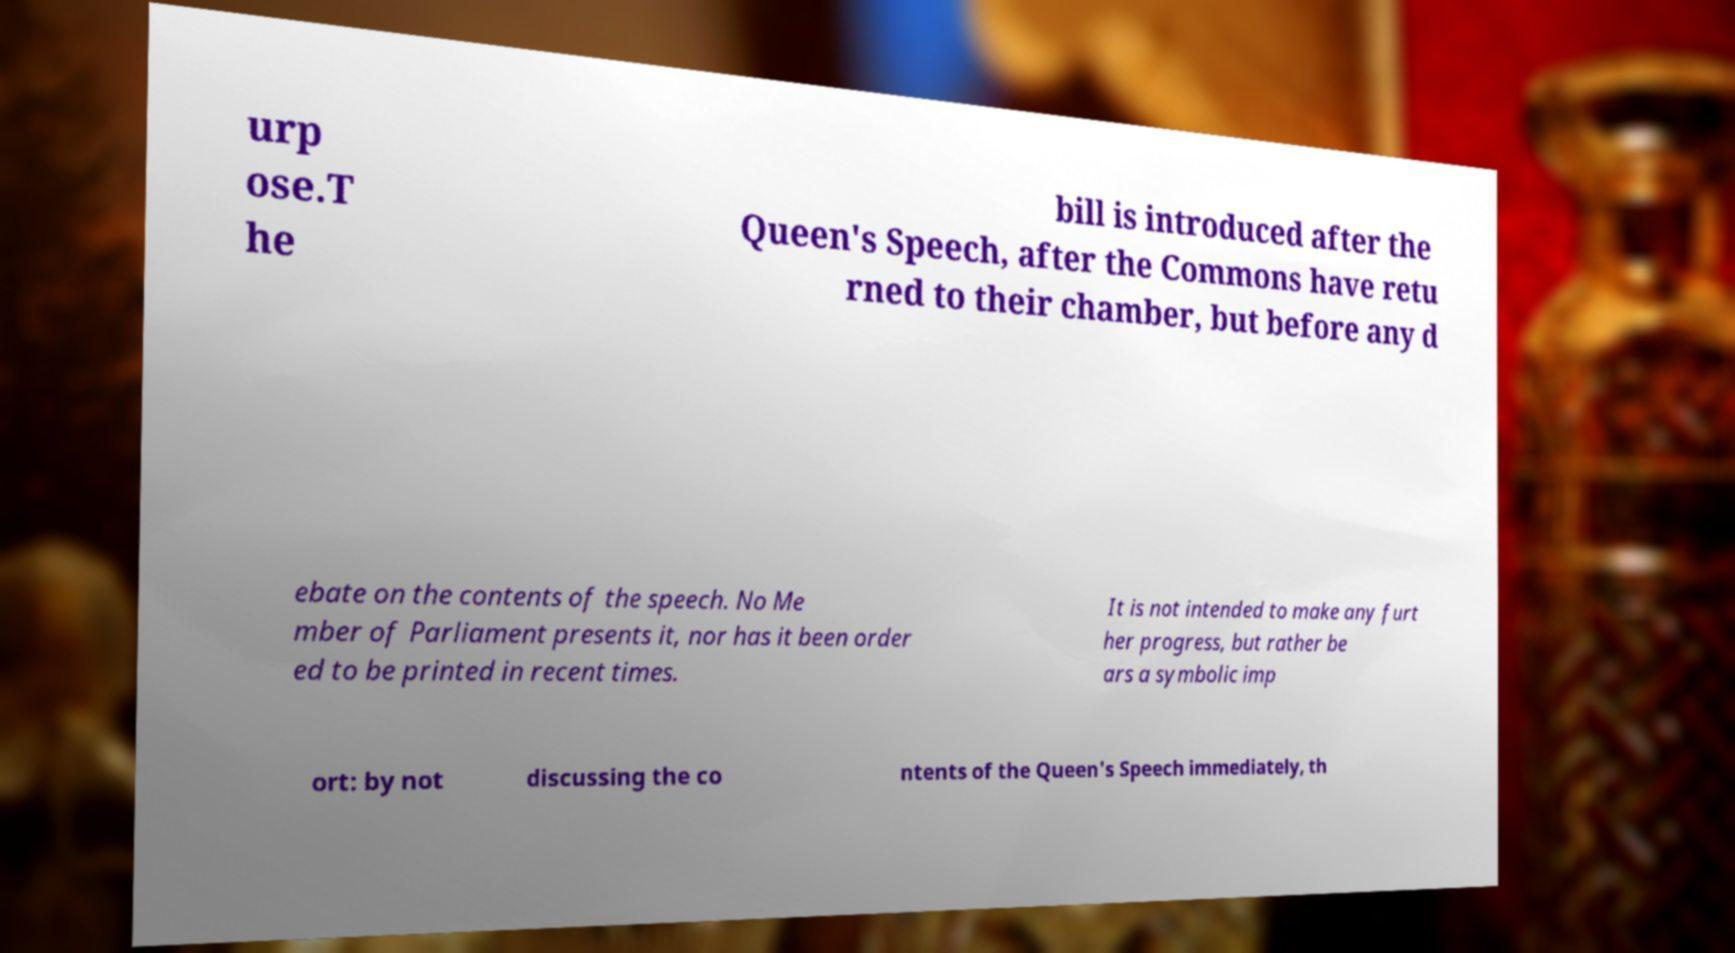Please identify and transcribe the text found in this image. urp ose.T he bill is introduced after the Queen's Speech, after the Commons have retu rned to their chamber, but before any d ebate on the contents of the speech. No Me mber of Parliament presents it, nor has it been order ed to be printed in recent times. It is not intended to make any furt her progress, but rather be ars a symbolic imp ort: by not discussing the co ntents of the Queen's Speech immediately, th 